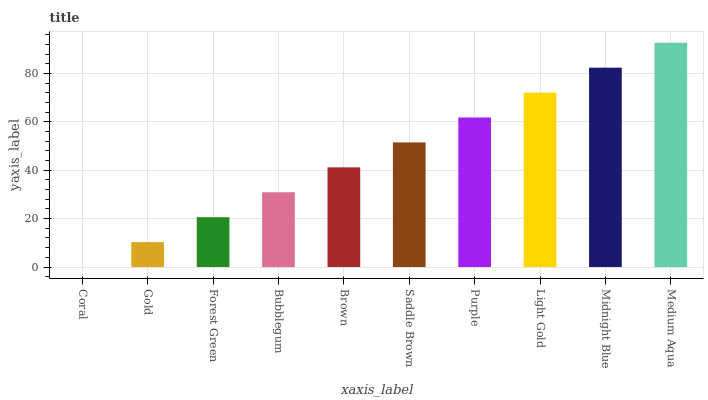Is Gold the minimum?
Answer yes or no. No. Is Gold the maximum?
Answer yes or no. No. Is Gold greater than Coral?
Answer yes or no. Yes. Is Coral less than Gold?
Answer yes or no. Yes. Is Coral greater than Gold?
Answer yes or no. No. Is Gold less than Coral?
Answer yes or no. No. Is Saddle Brown the high median?
Answer yes or no. Yes. Is Brown the low median?
Answer yes or no. Yes. Is Bubblegum the high median?
Answer yes or no. No. Is Coral the low median?
Answer yes or no. No. 